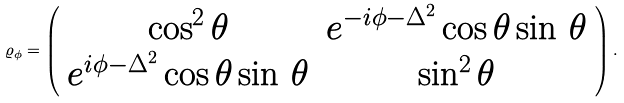<formula> <loc_0><loc_0><loc_500><loc_500>\varrho _ { \phi } = \left ( \begin{array} { c c } \cos ^ { 2 } \theta & e ^ { - i \phi - \Delta ^ { 2 } } \cos \theta \sin \, \theta \\ e ^ { i \phi - \Delta ^ { 2 } } \cos \theta \sin \, \theta & \sin ^ { 2 } \theta \end{array} \right ) .</formula> 